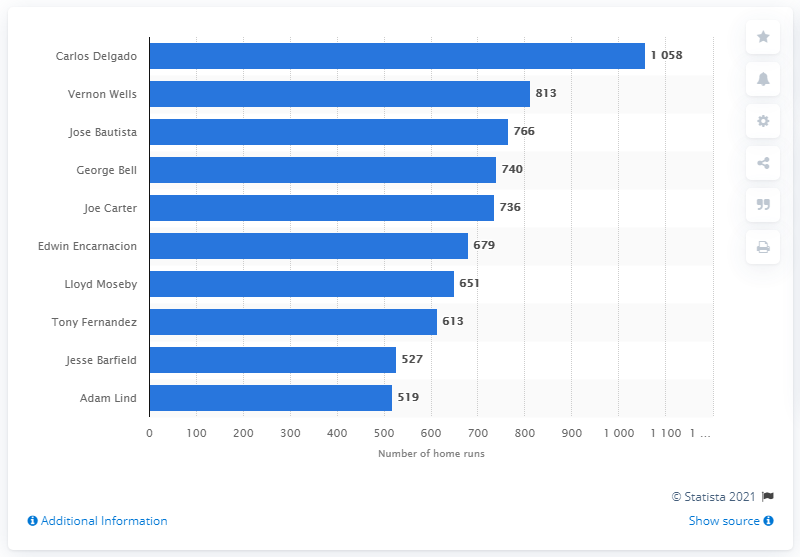Point out several critical features in this image. Carlos Delgado holds the record for the most RBI in New York Yankees franchise history. 